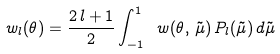Convert formula to latex. <formula><loc_0><loc_0><loc_500><loc_500>\ w _ { l } { ( \theta ) } = \frac { 2 \, l + 1 } { 2 } \int ^ { 1 } _ { - 1 } \ w { ( \theta , \, \tilde { \mu } ) } \, P _ { l } ( \tilde { \mu } ) \, d \tilde { \mu }</formula> 